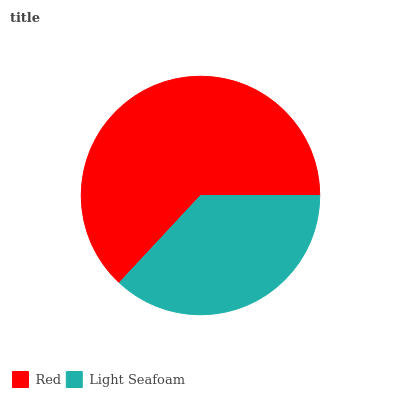Is Light Seafoam the minimum?
Answer yes or no. Yes. Is Red the maximum?
Answer yes or no. Yes. Is Light Seafoam the maximum?
Answer yes or no. No. Is Red greater than Light Seafoam?
Answer yes or no. Yes. Is Light Seafoam less than Red?
Answer yes or no. Yes. Is Light Seafoam greater than Red?
Answer yes or no. No. Is Red less than Light Seafoam?
Answer yes or no. No. Is Red the high median?
Answer yes or no. Yes. Is Light Seafoam the low median?
Answer yes or no. Yes. Is Light Seafoam the high median?
Answer yes or no. No. Is Red the low median?
Answer yes or no. No. 